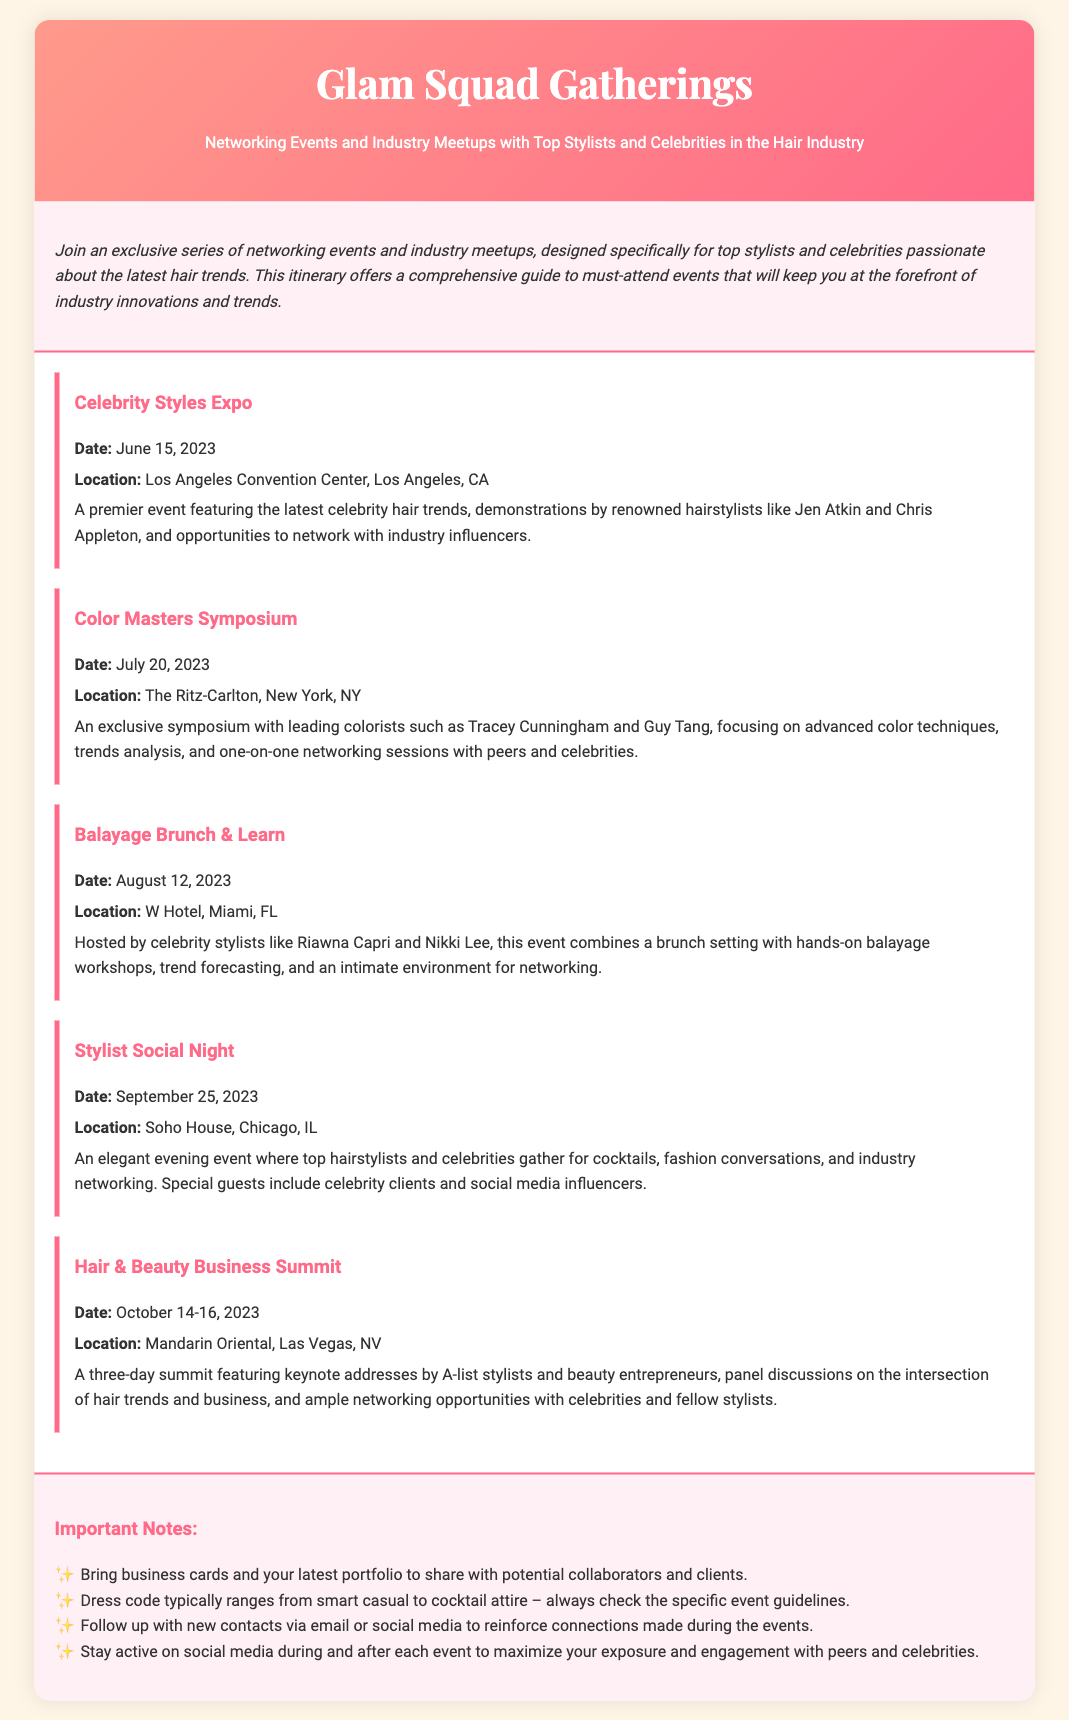what is the date of the Celebrity Styles Expo? The date of the Celebrity Styles Expo is June 15, 2023.
Answer: June 15, 2023 who are the hosts of the Balayage Brunch & Learn? The hosts of the Balayage Brunch & Learn are Riawna Capri and Nikki Lee.
Answer: Riawna Capri and Nikki Lee what is the location of the Hair & Beauty Business Summit? The location of the Hair & Beauty Business Summit is the Mandarin Oriental, Las Vegas, NV.
Answer: Mandarin Oriental, Las Vegas, NV how many days does the Hair & Beauty Business Summit last? The Hair & Beauty Business Summit lasts three days from October 14-16, 2023.
Answer: three days what type of event is the Stylist Social Night? The Stylist Social Night is an elegant evening event.
Answer: elegant evening event what is a key focus of the Color Masters Symposium? A key focus of the Color Masters Symposium is advanced color techniques.
Answer: advanced color techniques what should attendees bring to the events? Attendees should bring business cards and their latest portfolio.
Answer: business cards and latest portfolio what attire is generally expected at the events? The attire expected typically ranges from smart casual to cocktail attire.
Answer: smart casual to cocktail attire 